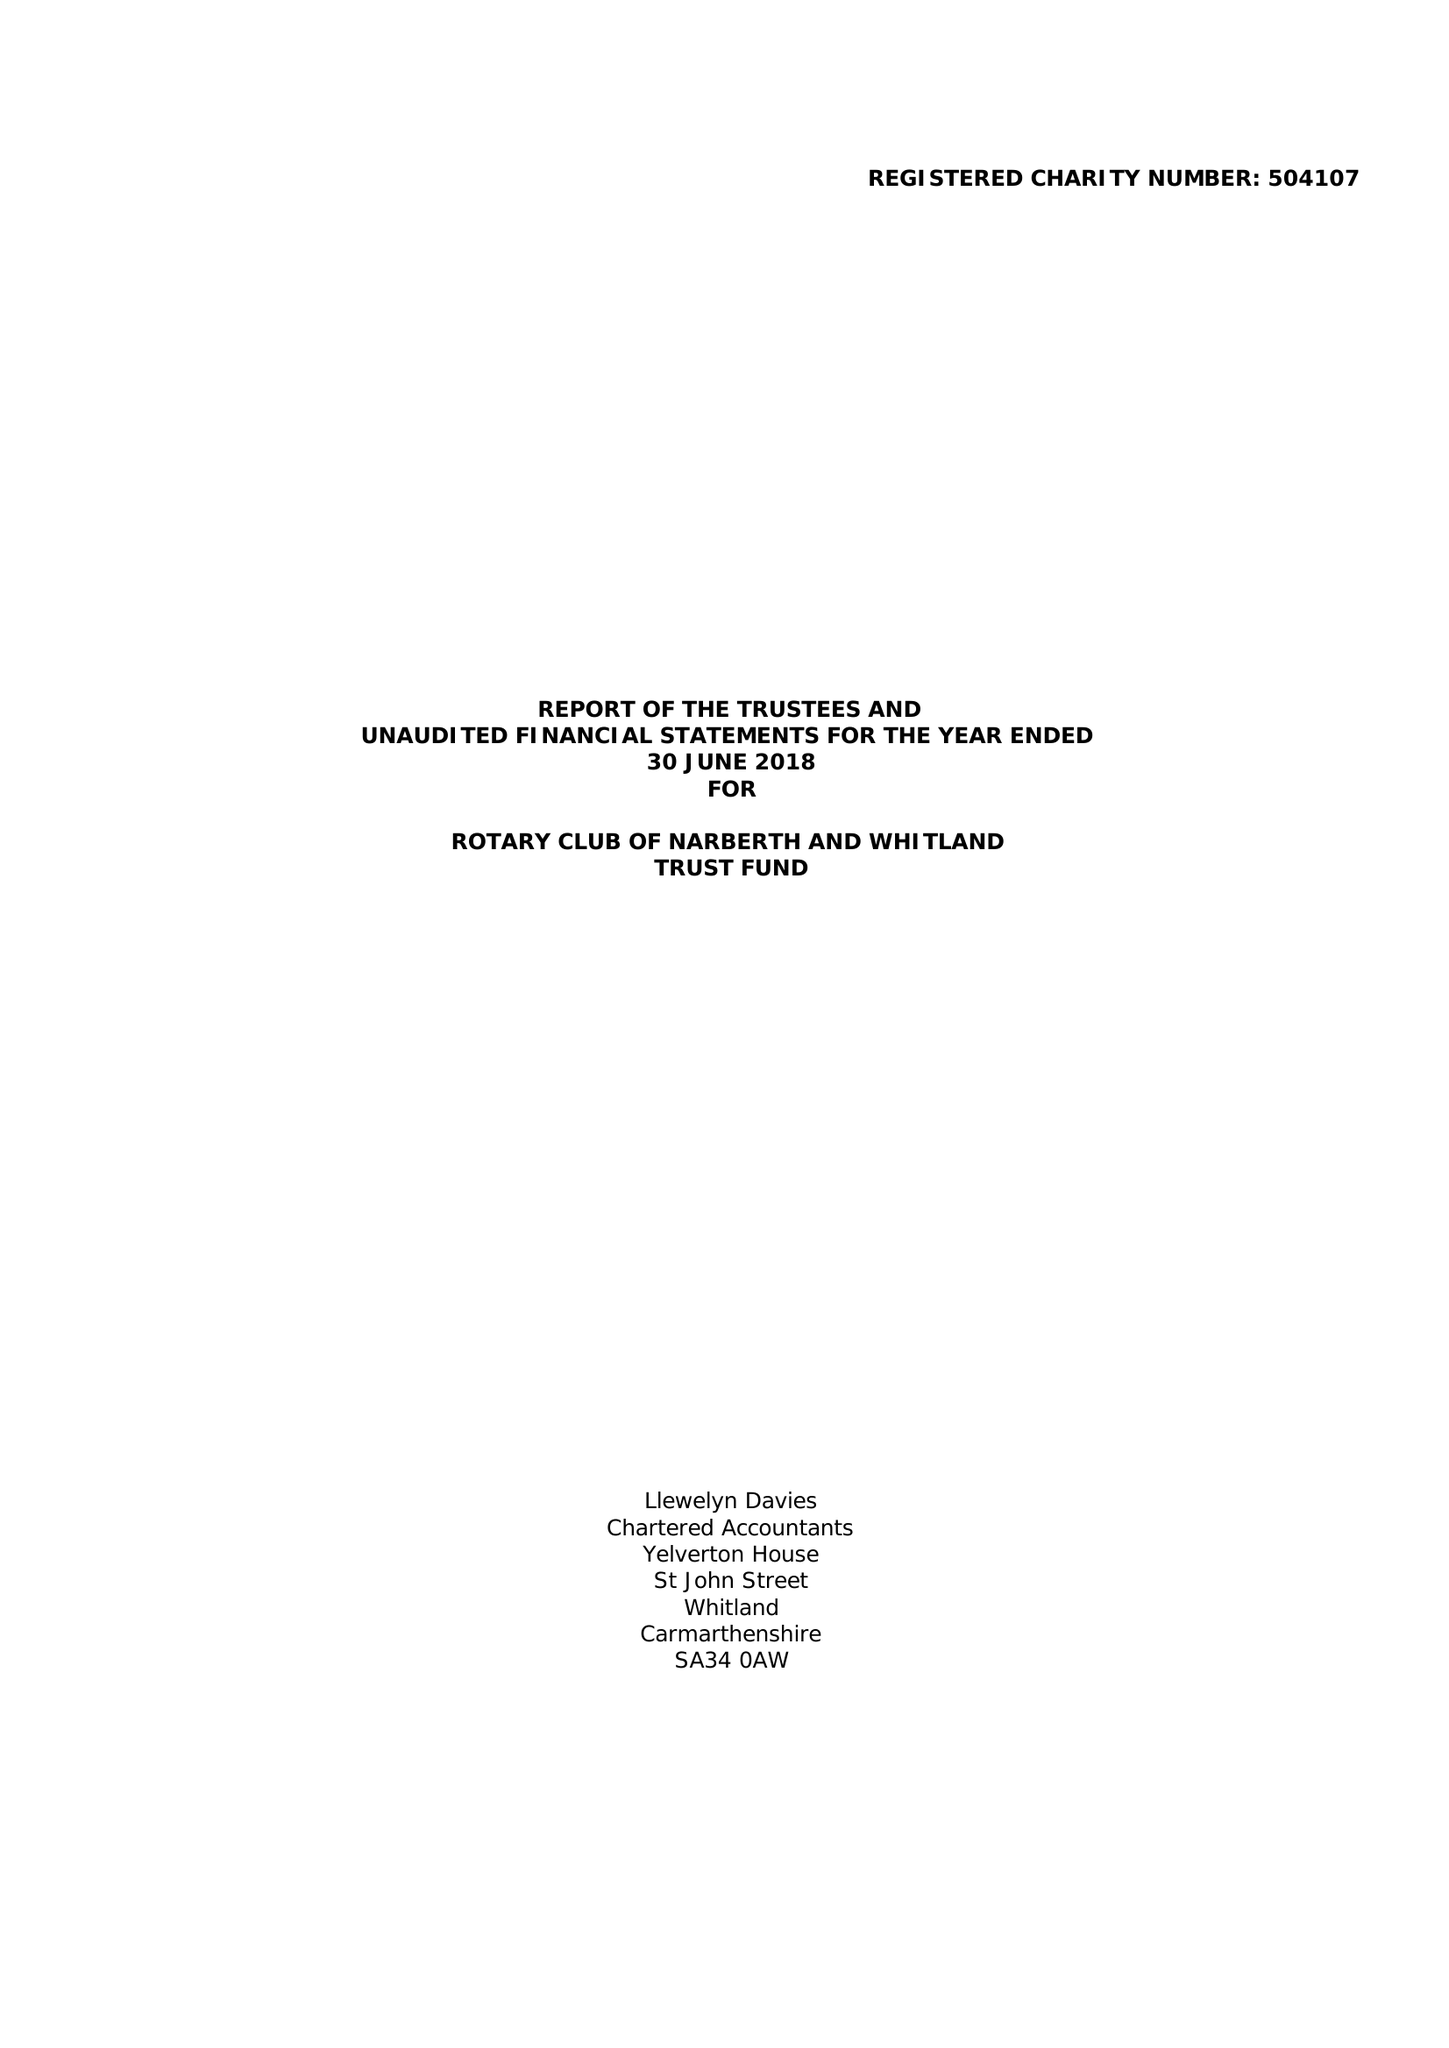What is the value for the charity_name?
Answer the question using a single word or phrase. Rotary Club Of Narberth and Whitland Trust Fund 